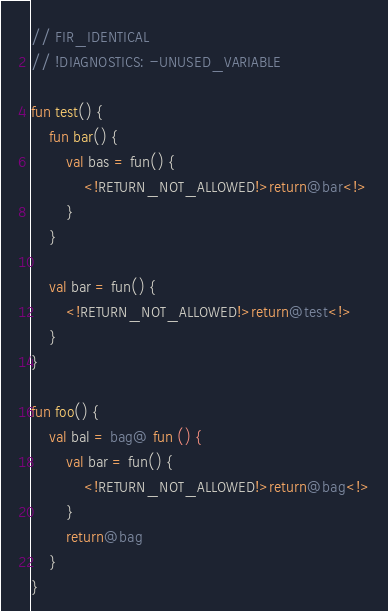<code> <loc_0><loc_0><loc_500><loc_500><_Kotlin_>// FIR_IDENTICAL
// !DIAGNOSTICS: -UNUSED_VARIABLE

fun test() {
    fun bar() {
        val bas = fun() {
            <!RETURN_NOT_ALLOWED!>return@bar<!>
        }
    }

    val bar = fun() {
        <!RETURN_NOT_ALLOWED!>return@test<!>
    }
}

fun foo() {
    val bal = bag@ fun () {
        val bar = fun() {
            <!RETURN_NOT_ALLOWED!>return@bag<!>
        }
        return@bag
    }
}</code> 